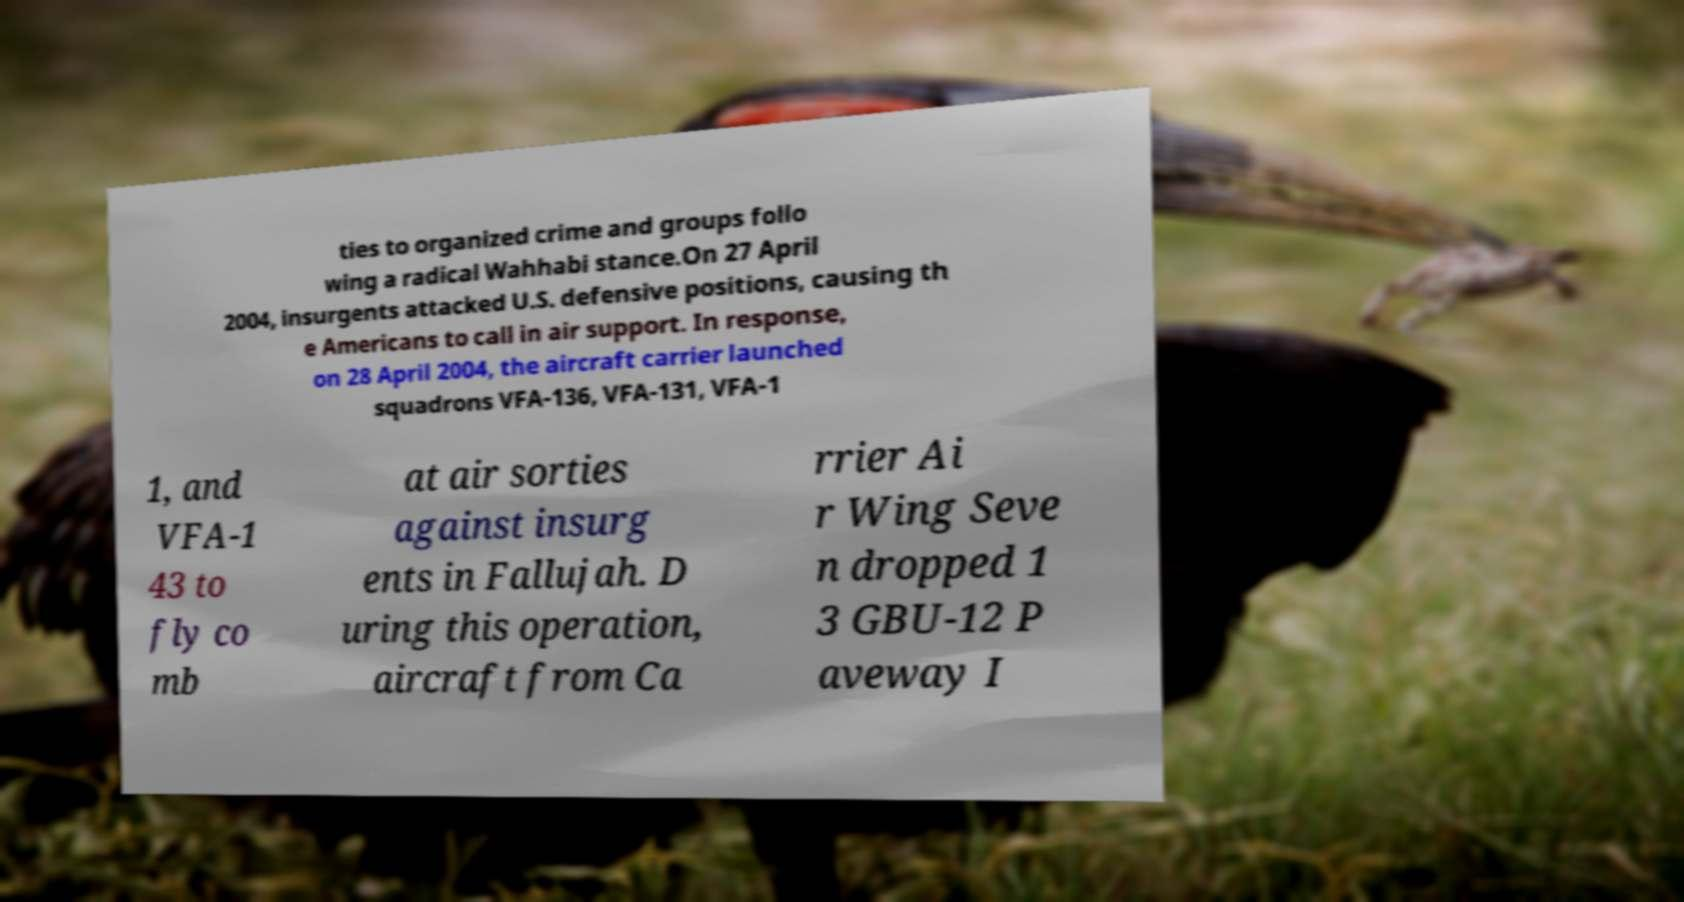Please read and relay the text visible in this image. What does it say? ties to organized crime and groups follo wing a radical Wahhabi stance.On 27 April 2004, insurgents attacked U.S. defensive positions, causing th e Americans to call in air support. In response, on 28 April 2004, the aircraft carrier launched squadrons VFA-136, VFA-131, VFA-1 1, and VFA-1 43 to fly co mb at air sorties against insurg ents in Fallujah. D uring this operation, aircraft from Ca rrier Ai r Wing Seve n dropped 1 3 GBU-12 P aveway I 